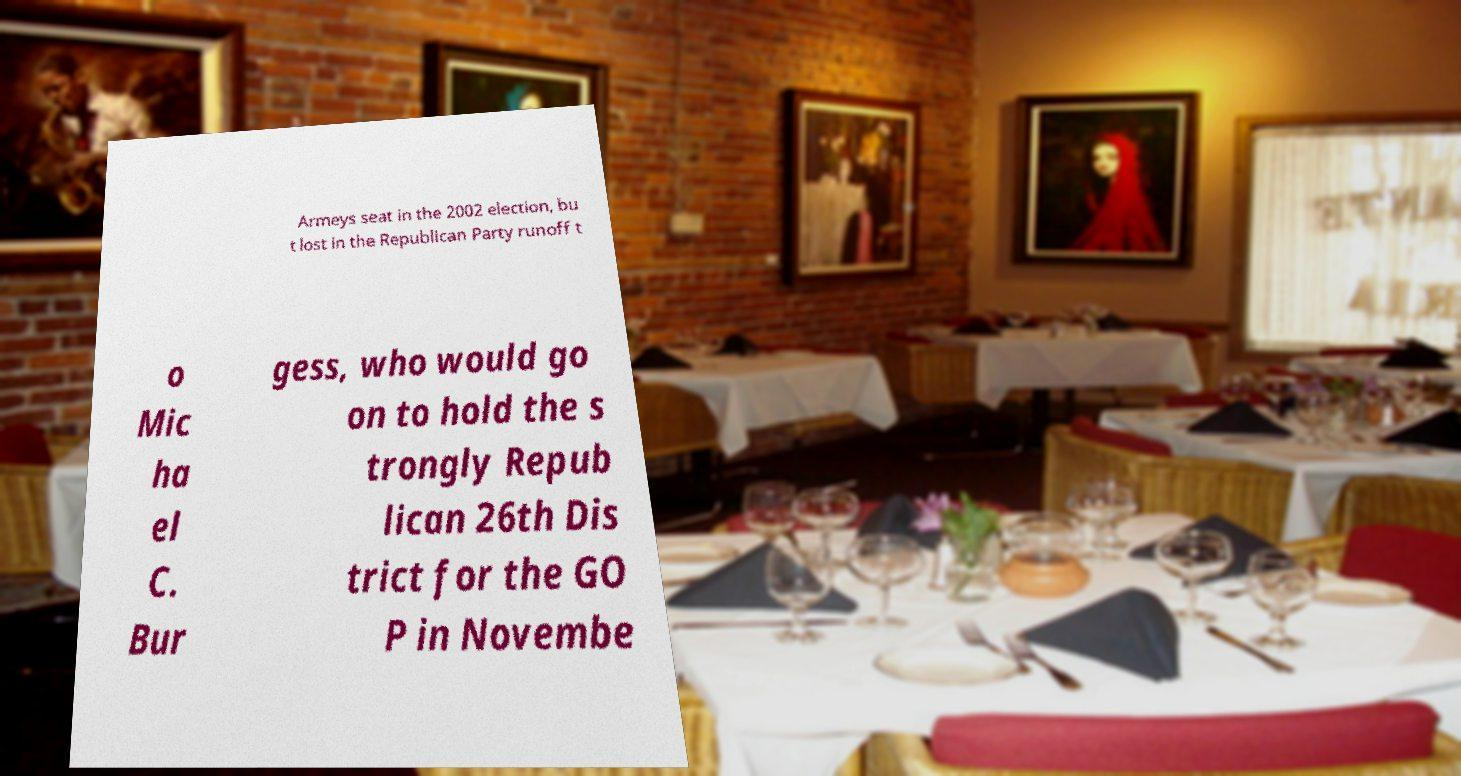I need the written content from this picture converted into text. Can you do that? Armeys seat in the 2002 election, bu t lost in the Republican Party runoff t o Mic ha el C. Bur gess, who would go on to hold the s trongly Repub lican 26th Dis trict for the GO P in Novembe 